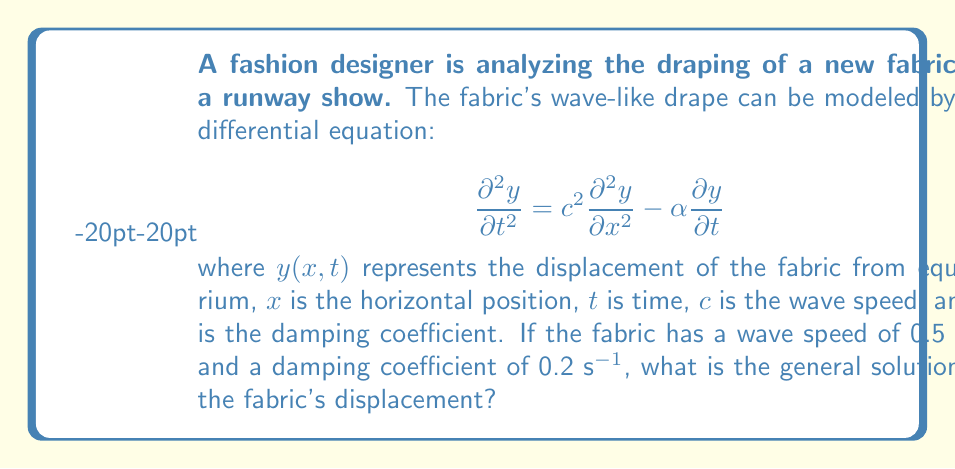Solve this math problem. To solve this problem, we need to follow these steps:

1) First, we recognize this equation as a damped wave equation. The general solution for such an equation is of the form:

   $$y(x,t) = e^{-\frac{\alpha t}{2}}[f(x-ct) + g(x+ct)]$$

   where $f$ and $g$ are arbitrary functions.

2) We're given that $c = 0.5$ m/s and $\alpha = 0.2$ s^-1.

3) Substituting these values into our general solution:

   $$y(x,t) = e^{-0.1t}[f(x-0.5t) + g(x+0.5t)]$$

4) This is our general solution. The functions $f$ and $g$ would be determined by the initial conditions and boundary conditions of the specific draping scenario, which are not provided in this problem.

5) The term $e^{-0.1t}$ represents the damping of the wave over time due to factors like air resistance or the fabric's internal friction.

6) The terms $(x-0.5t)$ and $(x+0.5t)$ represent the leftward and rightward traveling waves, respectively, moving at a speed of 0.5 m/s.
Answer: $$y(x,t) = e^{-0.1t}[f(x-0.5t) + g(x+0.5t)]$$ 